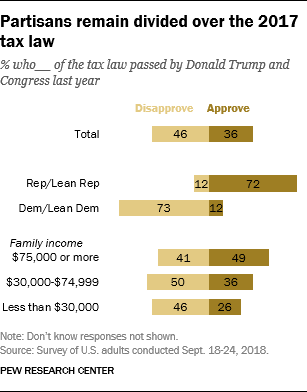Indicate a few pertinent items in this graphic. The value of "Approve" for Representatives and Lean Representatives is 72. The result of adding two "Disapprove" bars with the same value is 92. 